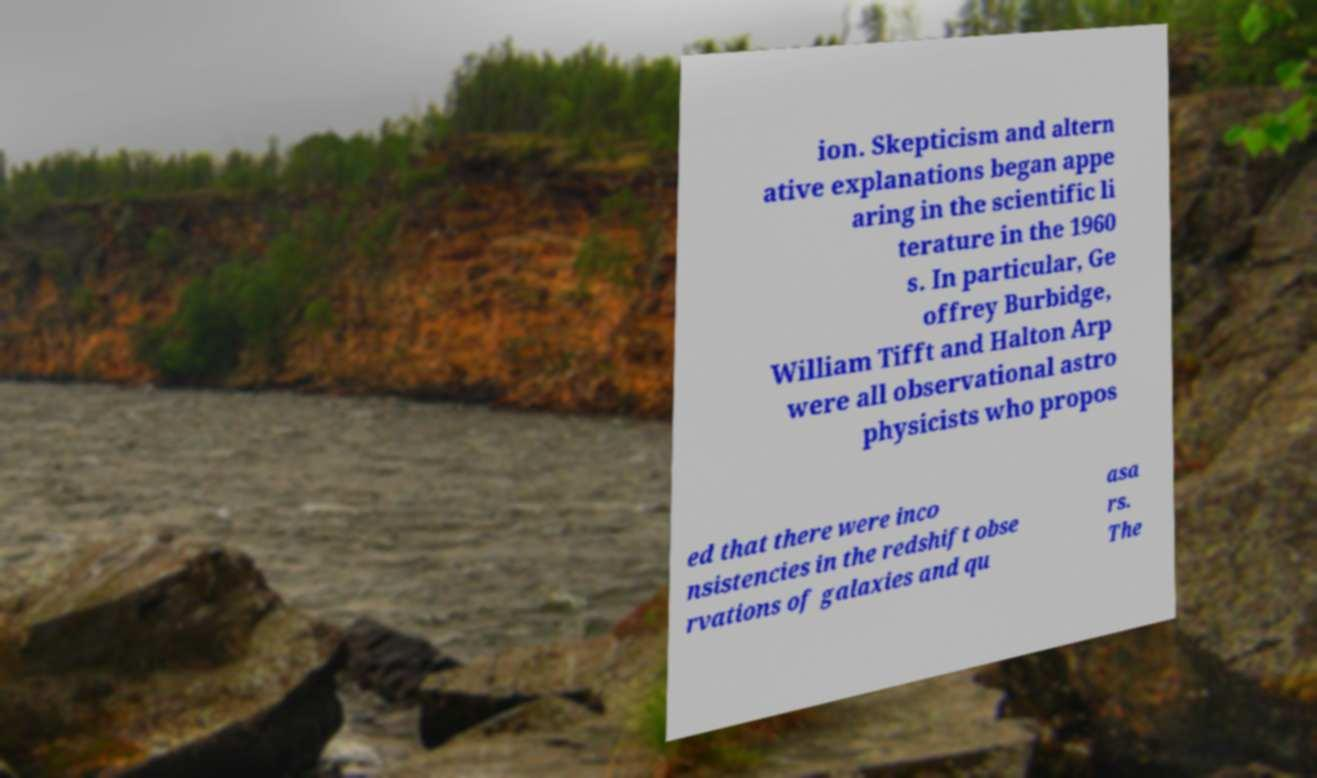Please read and relay the text visible in this image. What does it say? ion. Skepticism and altern ative explanations began appe aring in the scientific li terature in the 1960 s. In particular, Ge offrey Burbidge, William Tifft and Halton Arp were all observational astro physicists who propos ed that there were inco nsistencies in the redshift obse rvations of galaxies and qu asa rs. The 